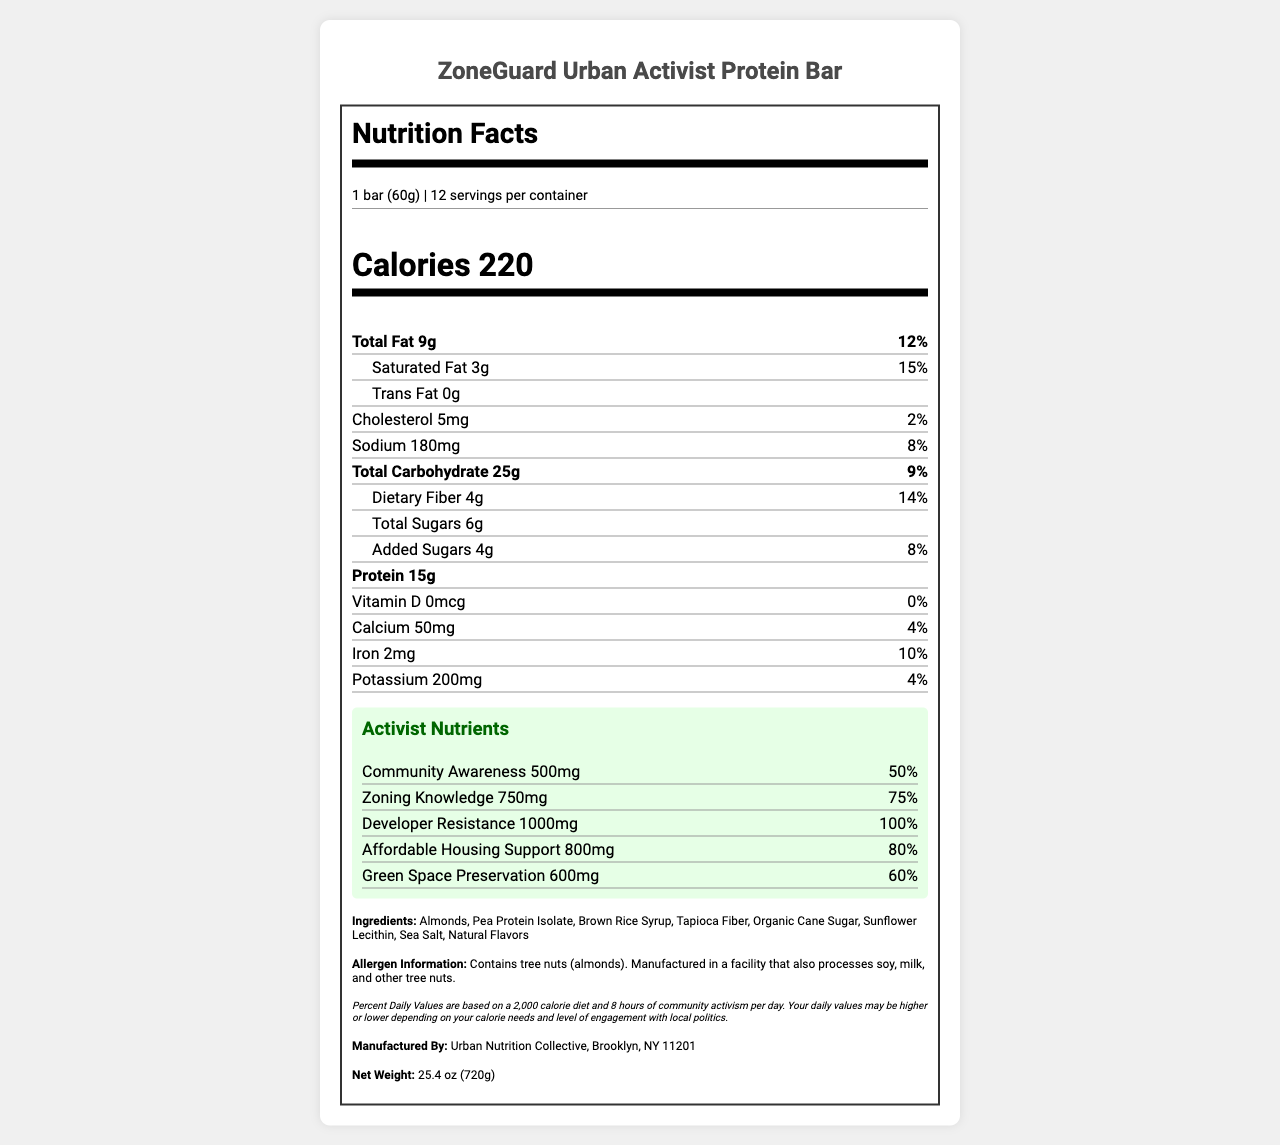what is the serving size? The serving size is clearly listed as "1 bar (60g)" on the Nutrition Facts label.
Answer: 1 bar (60g) how many calories are in one serving? The calories per serving are listed as 220 in the nutritional information section.
Answer: 220 what is the total fat content per serving? The total fat content per serving is listed as 9g under "Total Fat."
Answer: 9g how much dietary fiber is in one serving? The dietary fiber per serving is listed as 4g in the sub-section below "Total Carbohydrate."
Answer: 4g what are the main ingredients of the ZoneGuard Urban Activist Protein Bar? The ingredients are listed explicitly under the "Ingredients" section.
Answer: Almonds, Pea Protein Isolate, Brown Rice Syrup, Tapioca Fiber, Organic Cane Sugar, Sunflower Lecithin, Sea Salt, Natural Flavors which of these activist nutrients has the highest percentage of daily value? A. Community Awareness B. Zoning Knowledge C. Developer Resistance Developer Resistance has a percentage daily value of 100%, which is the highest among the activist nutrients listed.
Answer: C. Developer Resistance how much sodium is in one serving? A. 150mg B. 180mg C. 200mg The sodium content per serving is listed as 180mg under "Sodium."
Answer: B. 180mg is there any Vitamin D in the protein bar? Vitamin D is listed as having 0mcg and 0% daily value.
Answer: No does the ZoneGuard Urban Activist Protein Bar contain any allergens? The allergen information lists that the bar contains tree nuts (almonds) and is manufactured in a facility that also processes soy, milk, and other tree nuts.
Answer: Yes summarize the main idea of the document. The summary encapsulates the key sections and unique features of the Nutrition Facts label for the protein bar.
Answer: The document is a Nutrition Facts label for the ZoneGuard Urban Activist Protein Bar. It lists typical nutritional information such as serving size, calories, and macronutrients, as well as unique "activist nutrients" like Community Awareness and Developer Resistance. It includes ingredient and allergen information, a disclaimer about daily values, and manufacturing details. what is the total carbohydrate content per serving? The total carbohydrate content per serving is listed as 25g under "Total Carbohydrate."
Answer: 25g who manufactured the ZoneGuard Urban Activist Protein Bar? A. Uptown Protein Labs B. Urban Nutrition Collective C. Metropolis Health Foods The manufacturer is listed as "Urban Nutrition Collective" in the document.
Answer: B. Urban Nutrition Collective what city is the manufacturer based in? The manufacturer, Urban Nutrition Collective, is based in Brooklyn, NY, as stated under the "Manufactured By" section.
Answer: Brooklyn, NY how many grams of saturated fat are there per serving? The saturated fat content per serving is listed as 3g under "Saturated Fat."
Answer: 3g list three activist nutrients included in the ZoneGuard Urban Activist Protein Bar. The activist nutrients section lists several nutrients, among which Community Awareness, Zoning Knowledge, and Developer Resistance are three examples.
Answer: Community Awareness, Zoning Knowledge, Developer Resistance can the exact number of calories burned during 8 hours of community activism be determined from the document? The document does not provide information about the number of calories burned during 8 hours of community activism, only indicating that daily values may vary based on engagement levels.
Answer: No 